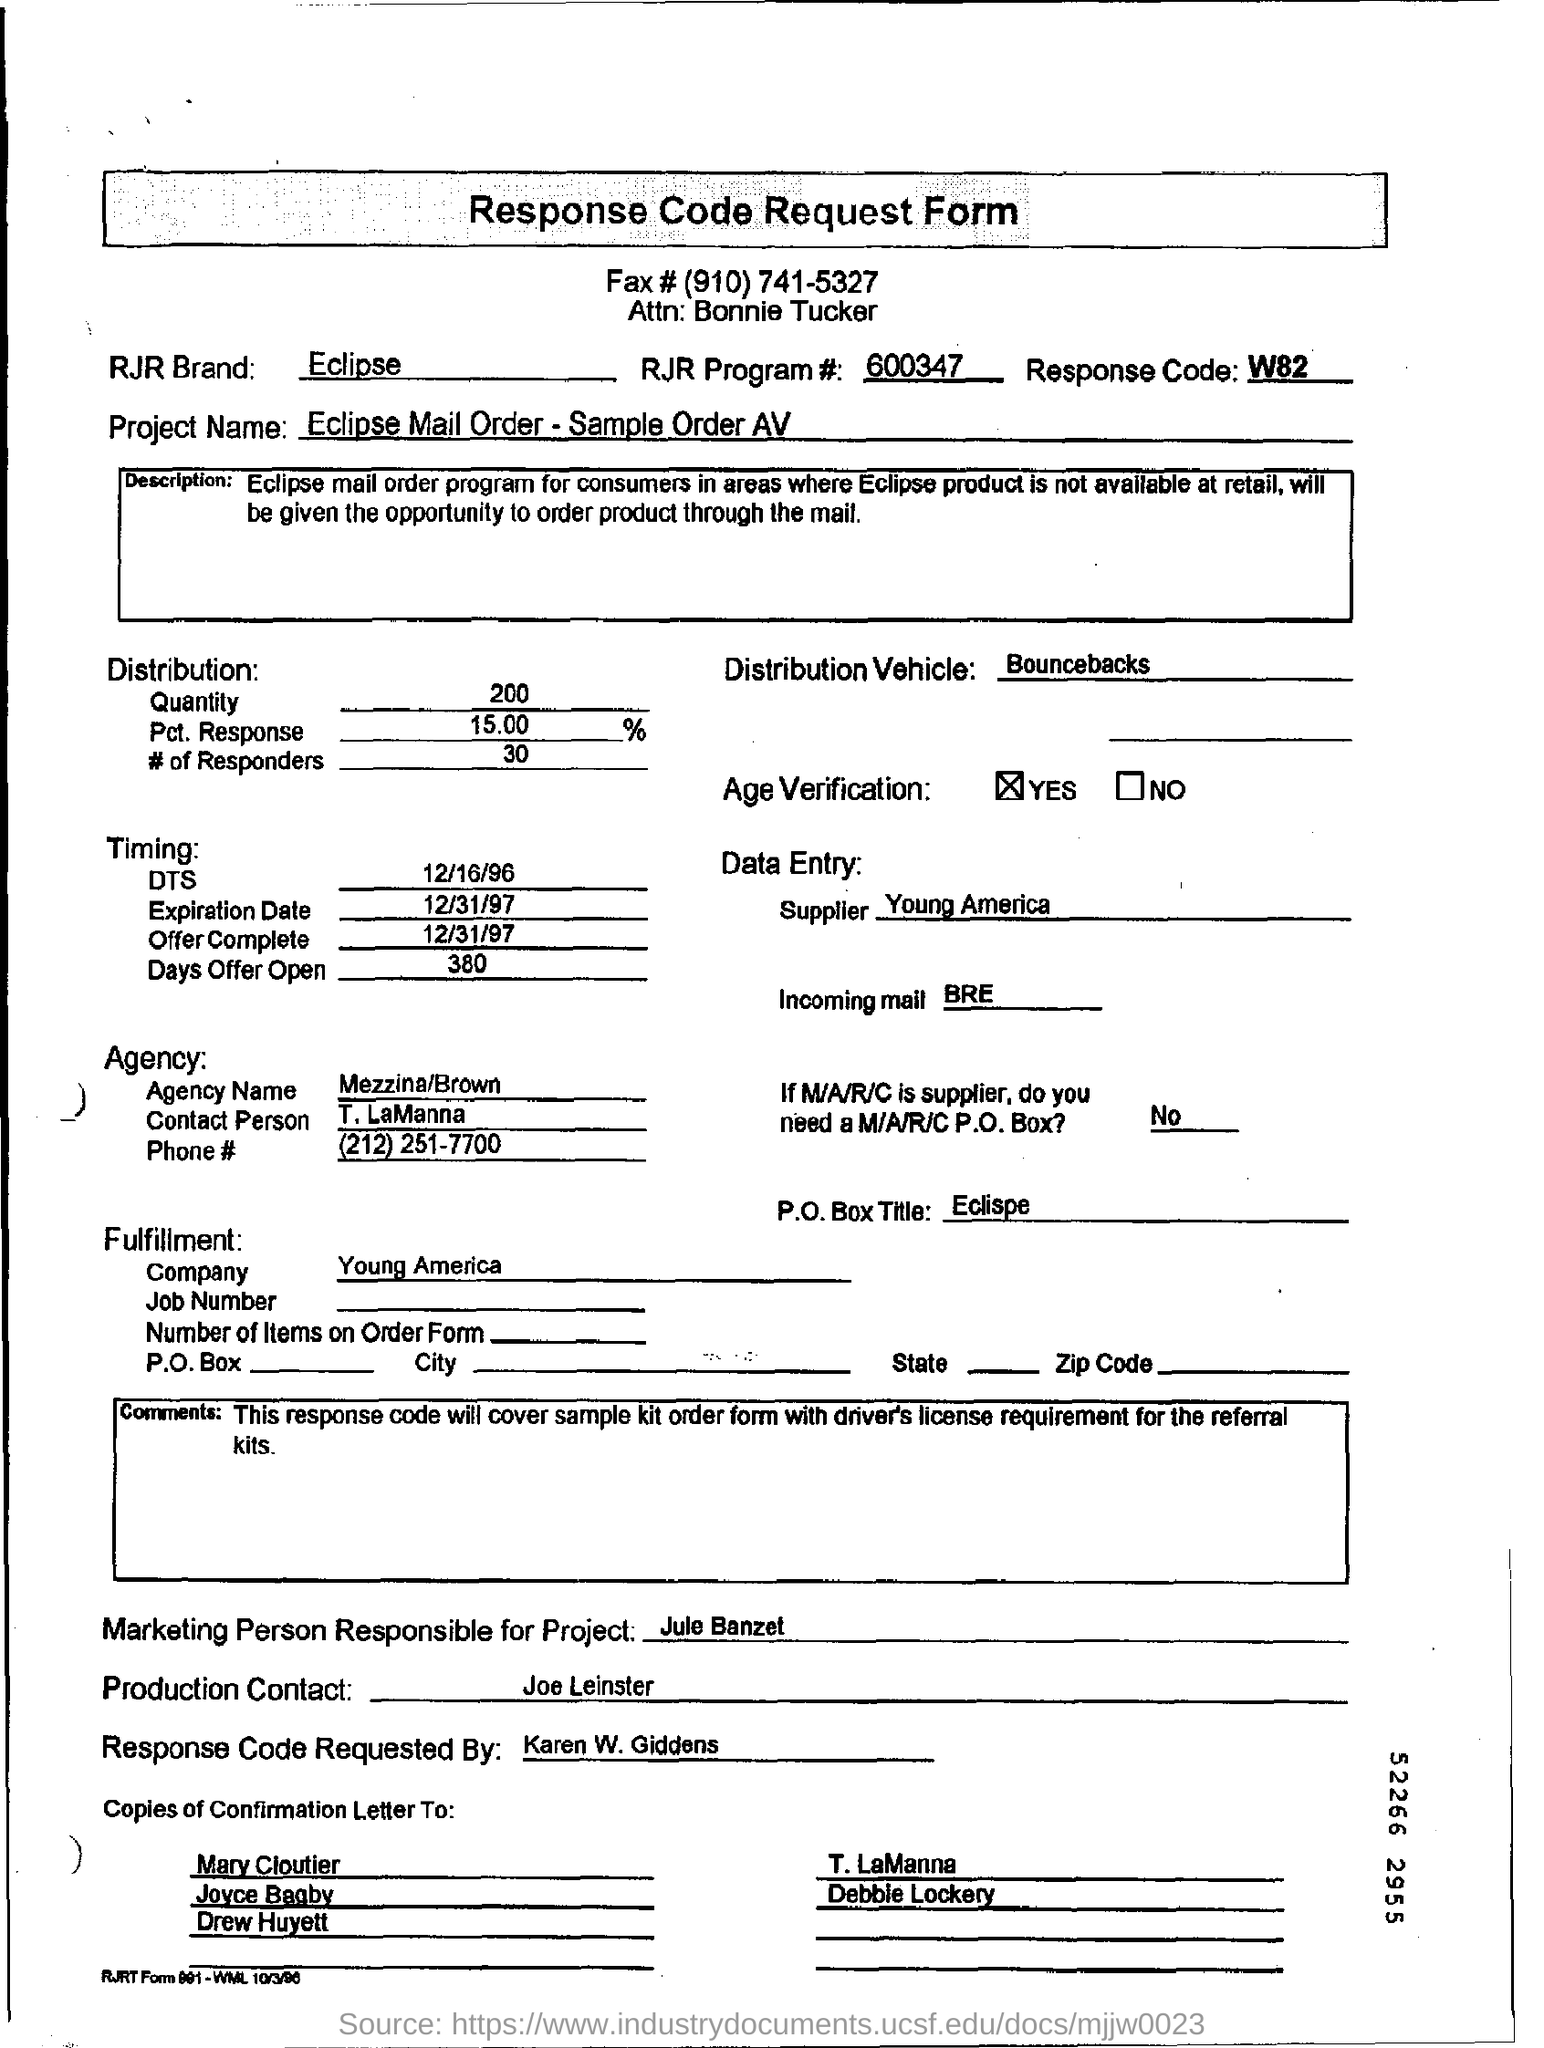What is the RJR Brand name?
Offer a terse response. Eclipse. What is the first name in the Copies of Confirmation Letter To column?
Provide a succinct answer. Mary Cloutier. Who is the Supplier mentioned in the Data Entry?
Make the answer very short. Young America. 